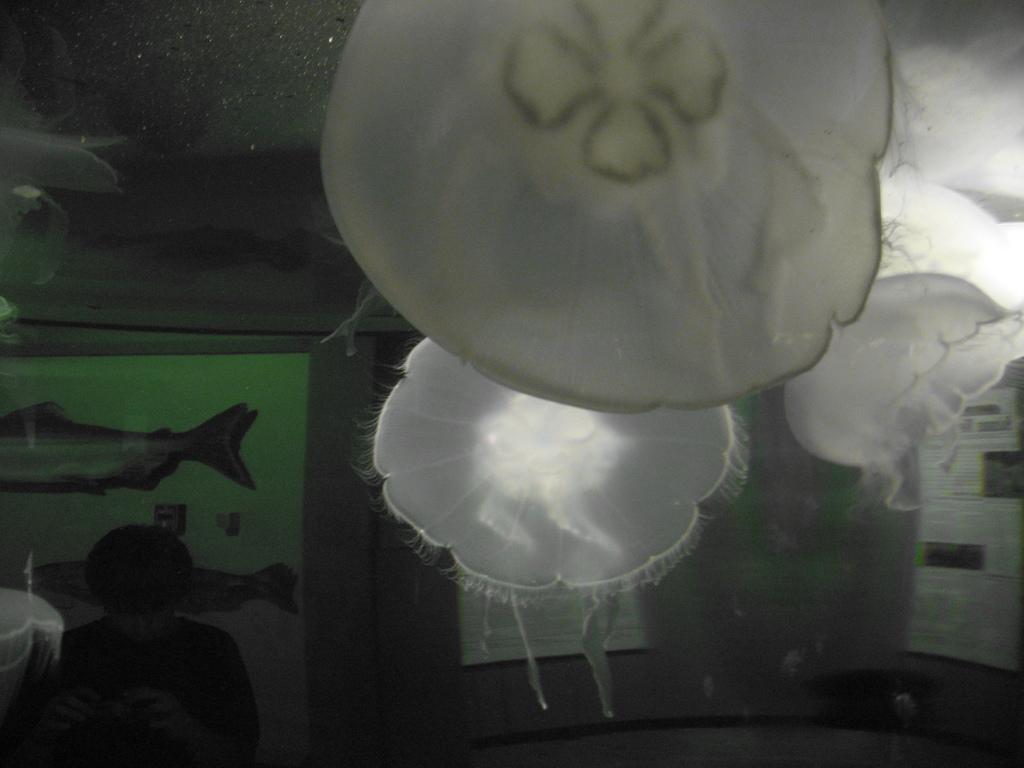How would you summarize this image in a sentence or two? In this picture we can see few jelly fishes and a person, and also we can see few papers. 